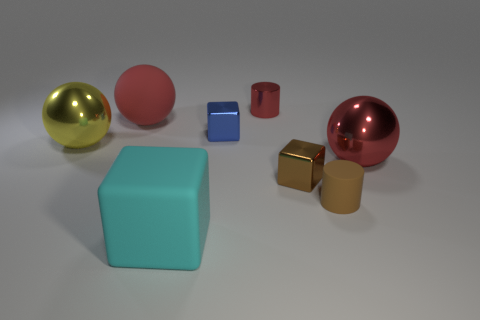Subtract all yellow cylinders. Subtract all gray spheres. How many cylinders are left? 2 Add 1 tiny matte things. How many objects exist? 9 Subtract all cylinders. How many objects are left? 6 Subtract all big blocks. Subtract all red metal cylinders. How many objects are left? 6 Add 8 large yellow objects. How many large yellow objects are left? 9 Add 6 cubes. How many cubes exist? 9 Subtract 1 red balls. How many objects are left? 7 